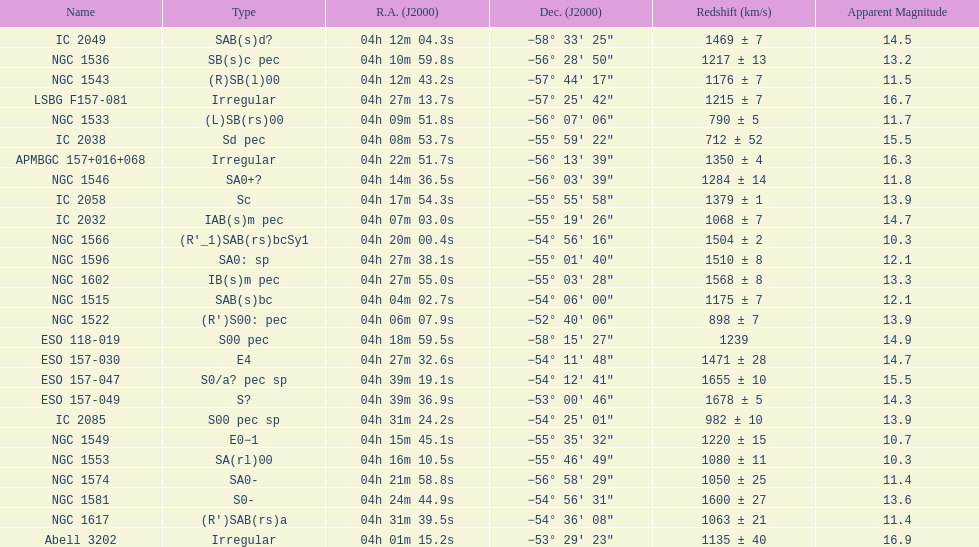What number of "irregular" types are there? 3. 